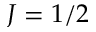Convert formula to latex. <formula><loc_0><loc_0><loc_500><loc_500>J = 1 / 2</formula> 